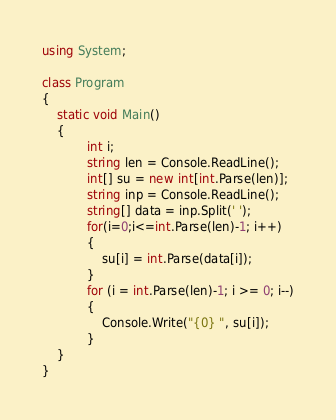<code> <loc_0><loc_0><loc_500><loc_500><_C#_>using System;

class Program
{
    static void Main()
    {
            int i;
            string len = Console.ReadLine();
            int[] su = new int[int.Parse(len)];
            string inp = Console.ReadLine();
            string[] data = inp.Split(' ');
            for(i=0;i<=int.Parse(len)-1; i++)
            {
                su[i] = int.Parse(data[i]);
            }
            for (i = int.Parse(len)-1; i >= 0; i--)
            {
                Console.Write("{0} ", su[i]);
            }
    }
}
</code> 